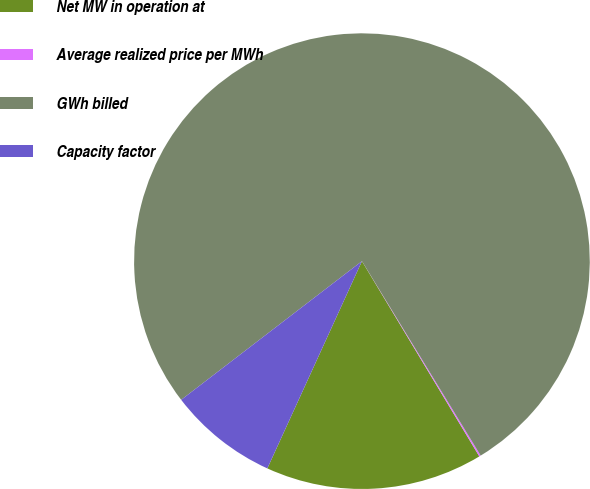Convert chart. <chart><loc_0><loc_0><loc_500><loc_500><pie_chart><fcel>Net MW in operation at<fcel>Average realized price per MWh<fcel>GWh billed<fcel>Capacity factor<nl><fcel>15.43%<fcel>0.11%<fcel>76.69%<fcel>7.77%<nl></chart> 